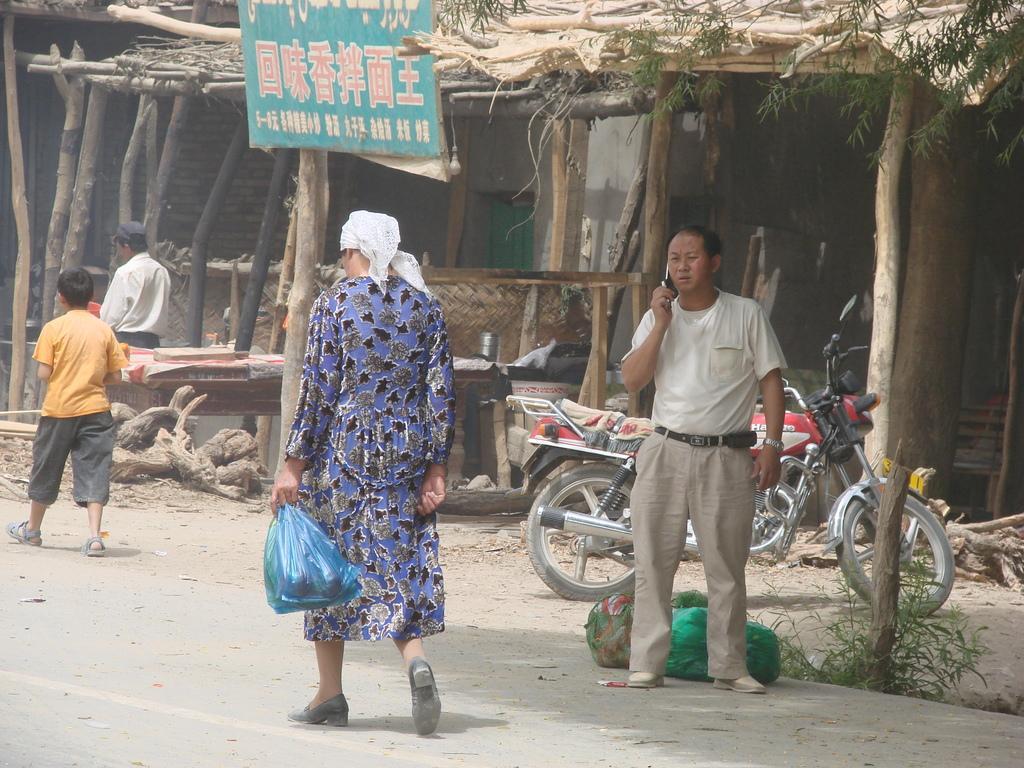Can you describe this image briefly? In the picture we can see a road on it we can see a woman walking with a cover bag and in front of her we can see a child walking and besides them we can see a man standing and talking in the mobile phone and behind him we can see a bike parked and a shed with wooden sticks and some board to the shed. 